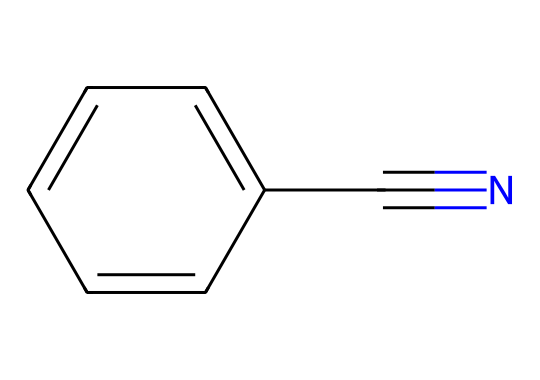How many carbon atoms are in benzonitrile? The structure shows a benzene ring which has 6 carbon atoms and an additional carbon atom attached to the nitrile group (C#N), making a total of 7 carbon atoms.
Answer: 7 What functional group is present in benzonitrile? The nitrile group (C#N) is a functional group characteristic of nitriles. The presence of this group indicates it is a nitrile compound.
Answer: nitrile What is the total number of hydrogen atoms in benzonitrile? The benzene ring has 5 hydrogen atoms (as one hydrogen is substituted by the nitrile group) and there are no additional hydrogens on the nitrile carbon. Thus, there are 5 hydrogen atoms in total.
Answer: 5 What is the molecular formula of benzonitrile? From the structure, we have 7 carbon atoms, 5 hydrogen atoms, and 1 nitrogen atom. Thus, the molecular formula is C7H5N.
Answer: C7H5N What type of unsaturation does the nitrile group introduce in benzonitrile? The nitrile group introduces a triple bond between carbon and nitrogen (C#N), which counts as one degree of unsaturation. Moreover, the benzene contributes another degree of unsaturation.
Answer: 2 How does the presence of the nitrile group affect the polarity of benzonitrile? The presence of the electronegative nitrogen in the nitrile group increases the overall polarity of the molecule compared to a hydrocarbon. This is due to the difference in electronegativity between carbon and nitrogen, resulting in a polar C-N bond.
Answer: increases polarity 